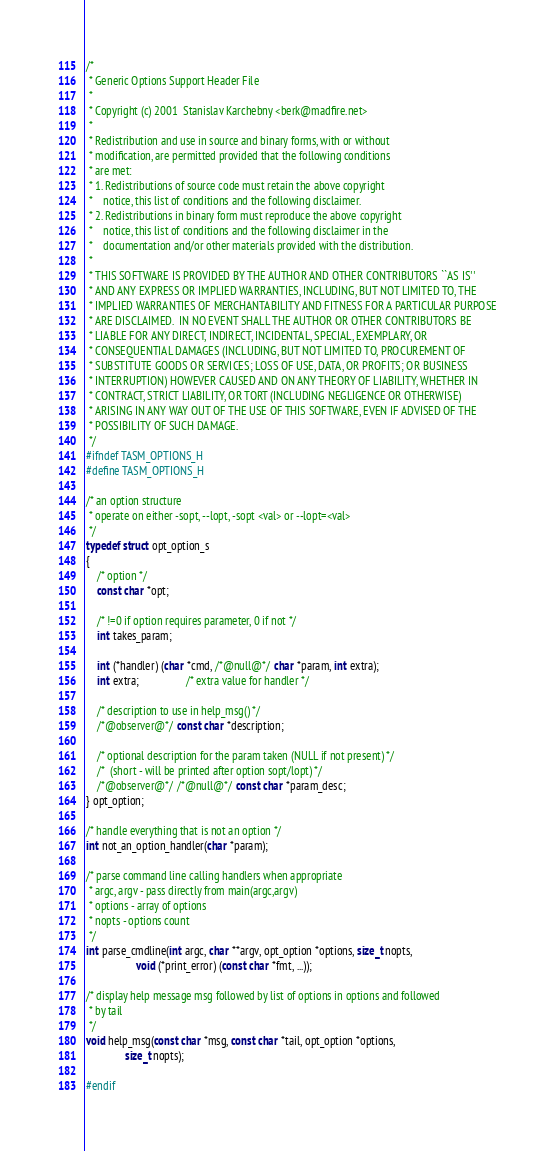Convert code to text. <code><loc_0><loc_0><loc_500><loc_500><_C_>/*
 * Generic Options Support Header File
 *
 * Copyright (c) 2001  Stanislav Karchebny <berk@madfire.net>
 *
 * Redistribution and use in source and binary forms, with or without
 * modification, are permitted provided that the following conditions
 * are met:
 * 1. Redistributions of source code must retain the above copyright
 *    notice, this list of conditions and the following disclaimer.
 * 2. Redistributions in binary form must reproduce the above copyright
 *    notice, this list of conditions and the following disclaimer in the
 *    documentation and/or other materials provided with the distribution.
 *
 * THIS SOFTWARE IS PROVIDED BY THE AUTHOR AND OTHER CONTRIBUTORS ``AS IS''
 * AND ANY EXPRESS OR IMPLIED WARRANTIES, INCLUDING, BUT NOT LIMITED TO, THE
 * IMPLIED WARRANTIES OF MERCHANTABILITY AND FITNESS FOR A PARTICULAR PURPOSE
 * ARE DISCLAIMED.  IN NO EVENT SHALL THE AUTHOR OR OTHER CONTRIBUTORS BE
 * LIABLE FOR ANY DIRECT, INDIRECT, INCIDENTAL, SPECIAL, EXEMPLARY, OR
 * CONSEQUENTIAL DAMAGES (INCLUDING, BUT NOT LIMITED TO, PROCUREMENT OF
 * SUBSTITUTE GOODS OR SERVICES; LOSS OF USE, DATA, OR PROFITS; OR BUSINESS
 * INTERRUPTION) HOWEVER CAUSED AND ON ANY THEORY OF LIABILITY, WHETHER IN
 * CONTRACT, STRICT LIABILITY, OR TORT (INCLUDING NEGLIGENCE OR OTHERWISE)
 * ARISING IN ANY WAY OUT OF THE USE OF THIS SOFTWARE, EVEN IF ADVISED OF THE
 * POSSIBILITY OF SUCH DAMAGE.
 */
#ifndef TASM_OPTIONS_H
#define TASM_OPTIONS_H

/* an option structure
 * operate on either -sopt, --lopt, -sopt <val> or --lopt=<val>
 */
typedef struct opt_option_s
{
    /* option */
    const char *opt;

    /* !=0 if option requires parameter, 0 if not */
    int takes_param;

    int (*handler) (char *cmd, /*@null@*/ char *param, int extra);
    int extra;                 /* extra value for handler */

    /* description to use in help_msg() */
    /*@observer@*/ const char *description;

    /* optional description for the param taken (NULL if not present) */
    /*  (short - will be printed after option sopt/lopt) */
    /*@observer@*/ /*@null@*/ const char *param_desc;
} opt_option;

/* handle everything that is not an option */
int not_an_option_handler(char *param);

/* parse command line calling handlers when appropriate
 * argc, argv - pass directly from main(argc,argv)
 * options - array of options
 * nopts - options count
 */
int parse_cmdline(int argc, char **argv, opt_option *options, size_t nopts,
                  void (*print_error) (const char *fmt, ...));

/* display help message msg followed by list of options in options and followed
 * by tail
 */
void help_msg(const char *msg, const char *tail, opt_option *options,
              size_t nopts);

#endif
</code> 